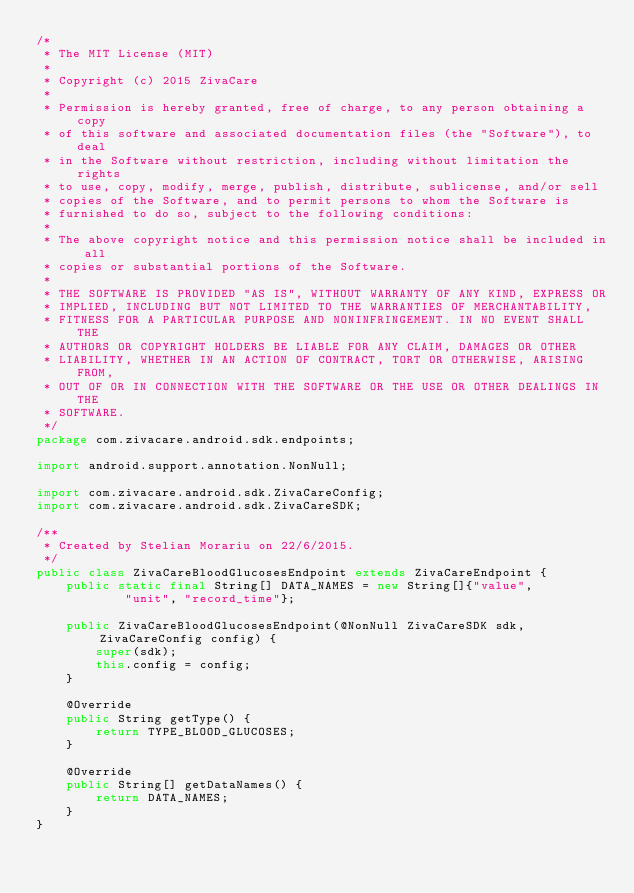Convert code to text. <code><loc_0><loc_0><loc_500><loc_500><_Java_>/*
 * The MIT License (MIT)
 *
 * Copyright (c) 2015 ZivaCare
 *
 * Permission is hereby granted, free of charge, to any person obtaining a copy
 * of this software and associated documentation files (the "Software"), to deal
 * in the Software without restriction, including without limitation the rights
 * to use, copy, modify, merge, publish, distribute, sublicense, and/or sell
 * copies of the Software, and to permit persons to whom the Software is
 * furnished to do so, subject to the following conditions:
 * 
 * The above copyright notice and this permission notice shall be included in all
 * copies or substantial portions of the Software.
 * 
 * THE SOFTWARE IS PROVIDED "AS IS", WITHOUT WARRANTY OF ANY KIND, EXPRESS OR
 * IMPLIED, INCLUDING BUT NOT LIMITED TO THE WARRANTIES OF MERCHANTABILITY,
 * FITNESS FOR A PARTICULAR PURPOSE AND NONINFRINGEMENT. IN NO EVENT SHALL THE
 * AUTHORS OR COPYRIGHT HOLDERS BE LIABLE FOR ANY CLAIM, DAMAGES OR OTHER
 * LIABILITY, WHETHER IN AN ACTION OF CONTRACT, TORT OR OTHERWISE, ARISING FROM,
 * OUT OF OR IN CONNECTION WITH THE SOFTWARE OR THE USE OR OTHER DEALINGS IN THE
 * SOFTWARE.
 */
package com.zivacare.android.sdk.endpoints;

import android.support.annotation.NonNull;

import com.zivacare.android.sdk.ZivaCareConfig;
import com.zivacare.android.sdk.ZivaCareSDK;

/**
 * Created by Stelian Morariu on 22/6/2015.
 */
public class ZivaCareBloodGlucosesEndpoint extends ZivaCareEndpoint {
    public static final String[] DATA_NAMES = new String[]{"value",
            "unit", "record_time"};

    public ZivaCareBloodGlucosesEndpoint(@NonNull ZivaCareSDK sdk,ZivaCareConfig config) {
        super(sdk);
        this.config = config;
    }

    @Override
    public String getType() {
        return TYPE_BLOOD_GLUCOSES;
    }

    @Override
    public String[] getDataNames() {
        return DATA_NAMES;
    }
}
</code> 